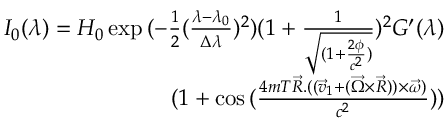Convert formula to latex. <formula><loc_0><loc_0><loc_500><loc_500>\begin{array} { r } { I _ { 0 } ( \lambda ) = H _ { 0 } \exp { ( - \frac { 1 } { 2 } ( \frac { \lambda - \lambda _ { 0 } } { \Delta \lambda } ) ^ { 2 } ) ( 1 + \frac { 1 } { \sqrt { ( 1 + \frac { 2 \phi } { c ^ { 2 } } ) } } ) ^ { 2 } } G ^ { \prime } ( \lambda ) } \\ { ( 1 + \cos { ( \frac { 4 m T \overrightarrow { R } . ( ( \overrightarrow { v } _ { 1 } + ( \overrightarrow { \Omega } \times \overrightarrow { R } ) ) \times \overrightarrow { \omega } ) } { c ^ { 2 } } ) } ) } \end{array}</formula> 